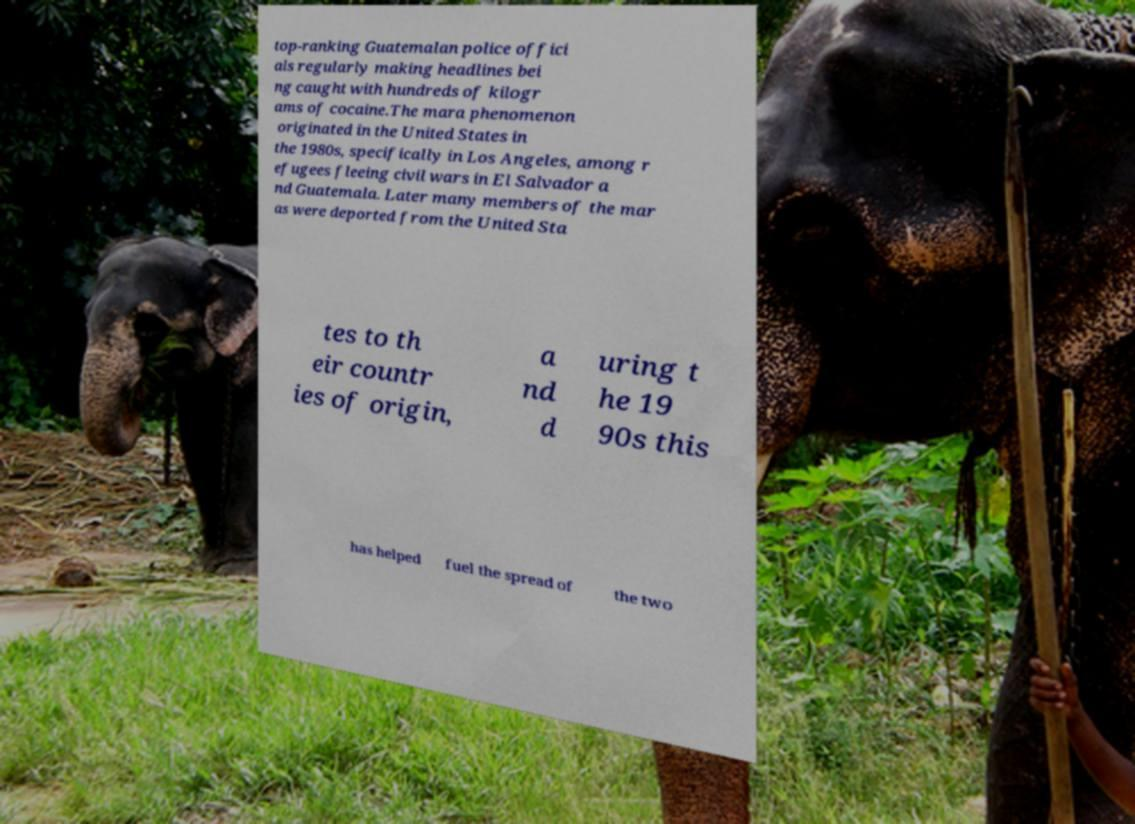Please read and relay the text visible in this image. What does it say? top-ranking Guatemalan police offici als regularly making headlines bei ng caught with hundreds of kilogr ams of cocaine.The mara phenomenon originated in the United States in the 1980s, specifically in Los Angeles, among r efugees fleeing civil wars in El Salvador a nd Guatemala. Later many members of the mar as were deported from the United Sta tes to th eir countr ies of origin, a nd d uring t he 19 90s this has helped fuel the spread of the two 